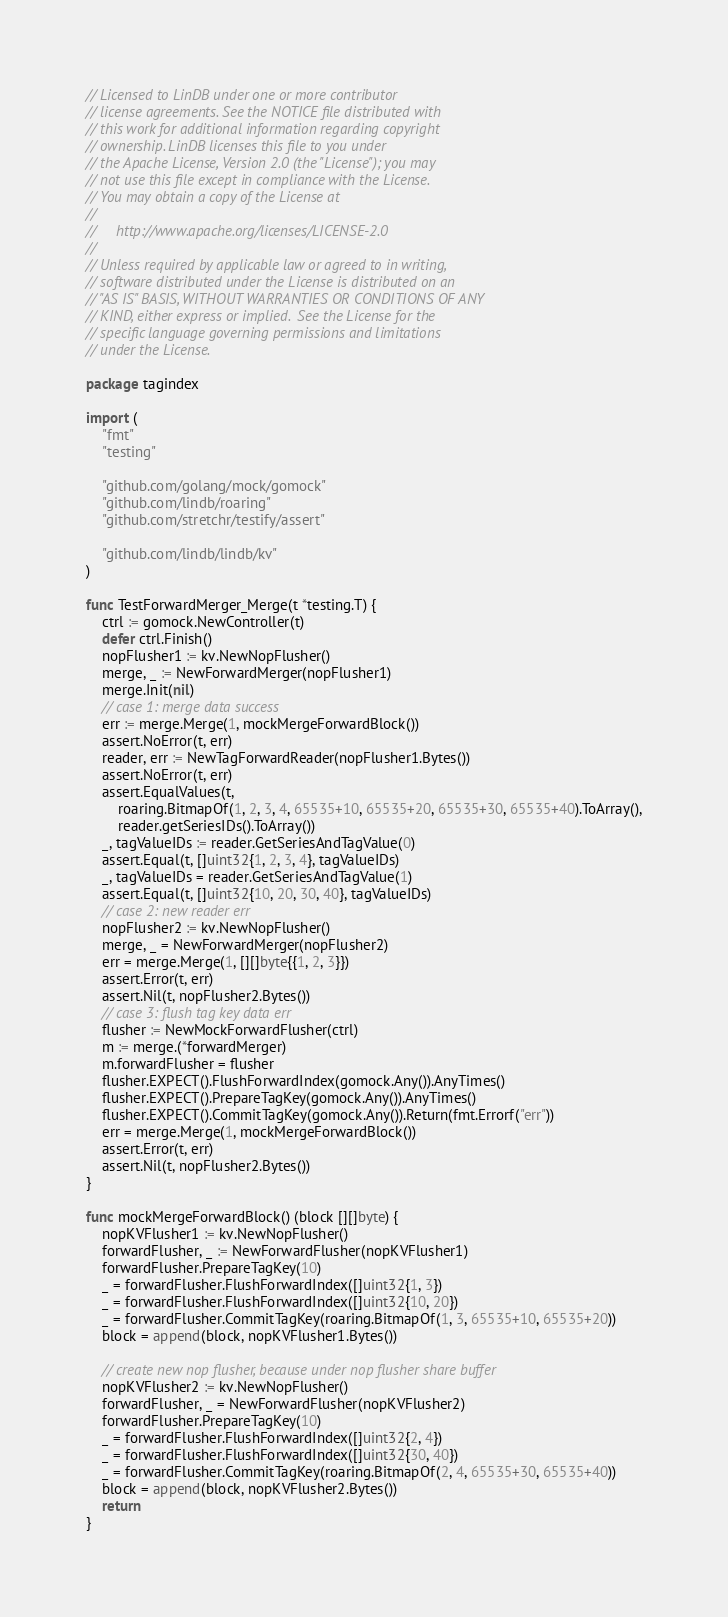<code> <loc_0><loc_0><loc_500><loc_500><_Go_>// Licensed to LinDB under one or more contributor
// license agreements. See the NOTICE file distributed with
// this work for additional information regarding copyright
// ownership. LinDB licenses this file to you under
// the Apache License, Version 2.0 (the "License"); you may
// not use this file except in compliance with the License.
// You may obtain a copy of the License at
//
//     http://www.apache.org/licenses/LICENSE-2.0
//
// Unless required by applicable law or agreed to in writing,
// software distributed under the License is distributed on an
// "AS IS" BASIS, WITHOUT WARRANTIES OR CONDITIONS OF ANY
// KIND, either express or implied.  See the License for the
// specific language governing permissions and limitations
// under the License.

package tagindex

import (
	"fmt"
	"testing"

	"github.com/golang/mock/gomock"
	"github.com/lindb/roaring"
	"github.com/stretchr/testify/assert"

	"github.com/lindb/lindb/kv"
)

func TestForwardMerger_Merge(t *testing.T) {
	ctrl := gomock.NewController(t)
	defer ctrl.Finish()
	nopFlusher1 := kv.NewNopFlusher()
	merge, _ := NewForwardMerger(nopFlusher1)
	merge.Init(nil)
	// case 1: merge data success
	err := merge.Merge(1, mockMergeForwardBlock())
	assert.NoError(t, err)
	reader, err := NewTagForwardReader(nopFlusher1.Bytes())
	assert.NoError(t, err)
	assert.EqualValues(t,
		roaring.BitmapOf(1, 2, 3, 4, 65535+10, 65535+20, 65535+30, 65535+40).ToArray(),
		reader.getSeriesIDs().ToArray())
	_, tagValueIDs := reader.GetSeriesAndTagValue(0)
	assert.Equal(t, []uint32{1, 2, 3, 4}, tagValueIDs)
	_, tagValueIDs = reader.GetSeriesAndTagValue(1)
	assert.Equal(t, []uint32{10, 20, 30, 40}, tagValueIDs)
	// case 2: new reader err
	nopFlusher2 := kv.NewNopFlusher()
	merge, _ = NewForwardMerger(nopFlusher2)
	err = merge.Merge(1, [][]byte{{1, 2, 3}})
	assert.Error(t, err)
	assert.Nil(t, nopFlusher2.Bytes())
	// case 3: flush tag key data err
	flusher := NewMockForwardFlusher(ctrl)
	m := merge.(*forwardMerger)
	m.forwardFlusher = flusher
	flusher.EXPECT().FlushForwardIndex(gomock.Any()).AnyTimes()
	flusher.EXPECT().PrepareTagKey(gomock.Any()).AnyTimes()
	flusher.EXPECT().CommitTagKey(gomock.Any()).Return(fmt.Errorf("err"))
	err = merge.Merge(1, mockMergeForwardBlock())
	assert.Error(t, err)
	assert.Nil(t, nopFlusher2.Bytes())
}

func mockMergeForwardBlock() (block [][]byte) {
	nopKVFlusher1 := kv.NewNopFlusher()
	forwardFlusher, _ := NewForwardFlusher(nopKVFlusher1)
	forwardFlusher.PrepareTagKey(10)
	_ = forwardFlusher.FlushForwardIndex([]uint32{1, 3})
	_ = forwardFlusher.FlushForwardIndex([]uint32{10, 20})
	_ = forwardFlusher.CommitTagKey(roaring.BitmapOf(1, 3, 65535+10, 65535+20))
	block = append(block, nopKVFlusher1.Bytes())

	// create new nop flusher, because under nop flusher share buffer
	nopKVFlusher2 := kv.NewNopFlusher()
	forwardFlusher, _ = NewForwardFlusher(nopKVFlusher2)
	forwardFlusher.PrepareTagKey(10)
	_ = forwardFlusher.FlushForwardIndex([]uint32{2, 4})
	_ = forwardFlusher.FlushForwardIndex([]uint32{30, 40})
	_ = forwardFlusher.CommitTagKey(roaring.BitmapOf(2, 4, 65535+30, 65535+40))
	block = append(block, nopKVFlusher2.Bytes())
	return
}
</code> 